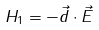Convert formula to latex. <formula><loc_0><loc_0><loc_500><loc_500>H _ { 1 } = - \vec { d } \cdot \vec { E }</formula> 